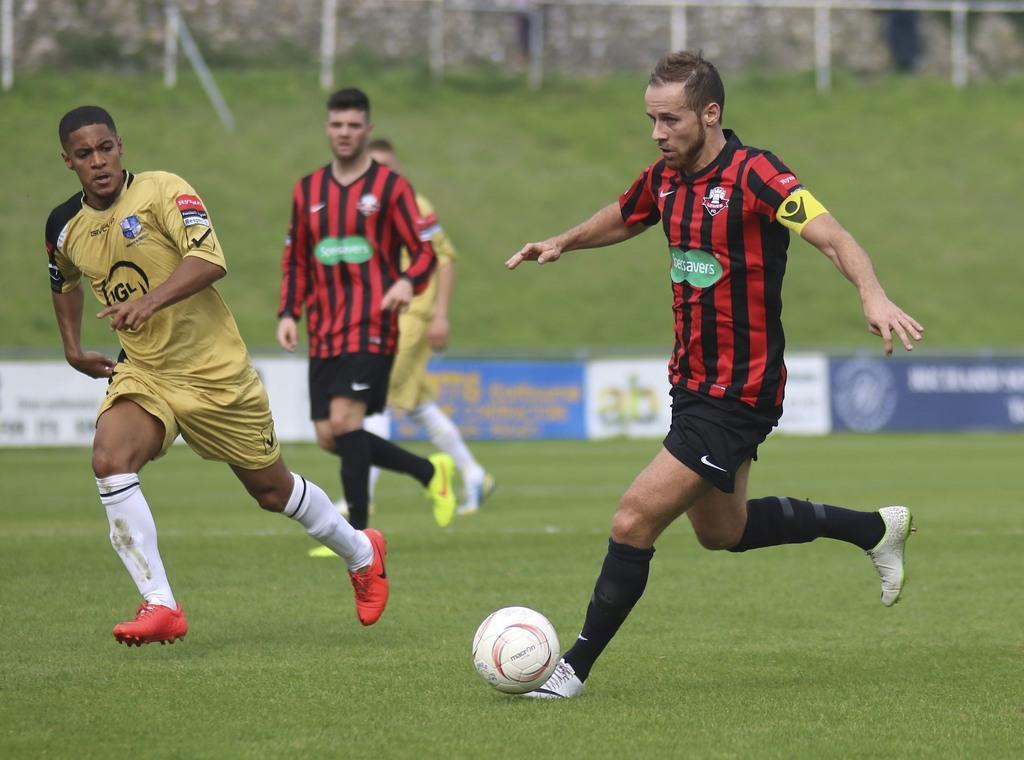Please provide a concise description of this image. In this picture we can see four persons are running on the ball, they are on the grass and in background we can see banners fence. 